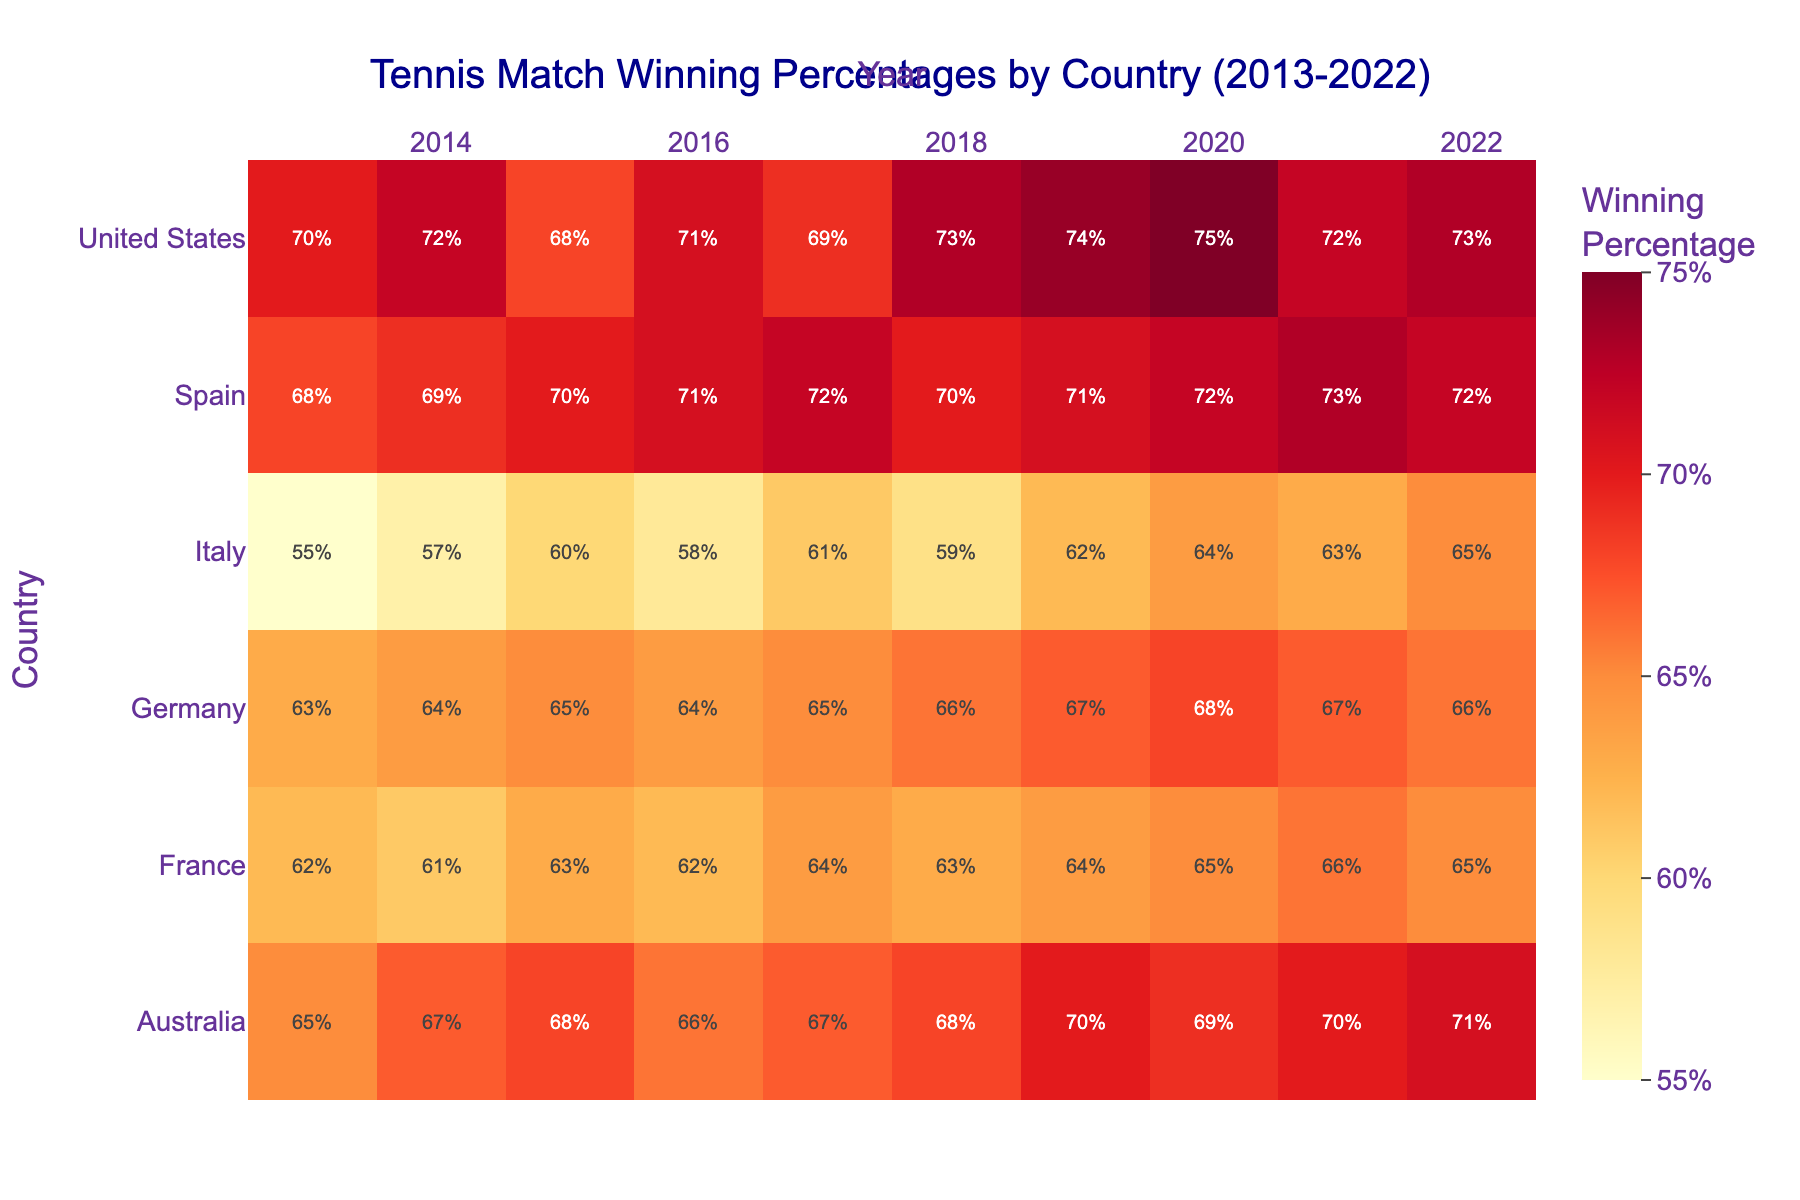What's the title of the heatmap? The title is typically displayed at the top of the figure. It provides a summary of the data presented in the heatmap. The title in this case is clearly stated at the top.
Answer: Tennis Match Winning Percentages by Country (2013-2022) What are the countries included in the heatmap? The countries are listed on the vertical axis (y-axis) of the heatmap. Each row corresponds to a different country.
Answer: Italy, United States, Spain, Australia, Germany, France Which country had the highest winning percentage in 2020? Look at the 2020 column and find the highest value. The country corresponding to this value is the one with the highest winning percentage.
Answer: United States Which year had the lowest winning percentage for Italy? Look at the row for Italy and find the lowest value. Then, check which year this value corresponds to by looking at the column headings.
Answer: 2013 What is the range of winning percentages displayed in the heatmap? To find the range, look at the color bar which indicates the range of winning percentages, typically displayed on the side.
Answer: 55% to 75% Which country showed the most improvement in winning percentage over the decade? Calculate the difference in winning percentages between 2013 and 2022 for each country. The country with the largest positive difference shows the most improvement.
Answer: Italy Compare the winning percentages of Spain and Australia in 2015. Which country had a higher percentage? Look at the 2015 column, then compare the values for Spain and Australia by checking their respective rows.
Answer: Spain How does the winning percentage of Germany in 2014 compare to its percentage in 2022? Check the winning percentage for Germany in the 2014 column and then in the 2022 column. Compare these two values.
Answer: The percentage in 2014 is 64%, and in 2022 it is 66% What is the average winning percentage for France over the decade? Sum the winning percentages for France from 2013 to 2022, then divide by the number of years (10).
Answer: (62 + 61 + 63 + 62 + 64 + 63 + 64 + 65 + 66 + 65) / 10 = 63.5% Identify one year where the United States had a decline in winning percentage compared to the previous year. Look at the trend in the United States’ row. Identify years where the value is lower than the previous year.
Answer: 2015 Which country has the least variance in winning percentage over the decade? Calculate the variance (measure of spread) for each country's winning percentages from 2013-2022. The country with the smallest variance has the most consistent performance.
Answer: Spain 